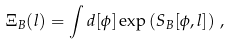<formula> <loc_0><loc_0><loc_500><loc_500>\Xi _ { B } ( l ) = \int d [ \phi ] \exp \left ( S _ { B } [ \phi , l ] \right ) \, ,</formula> 